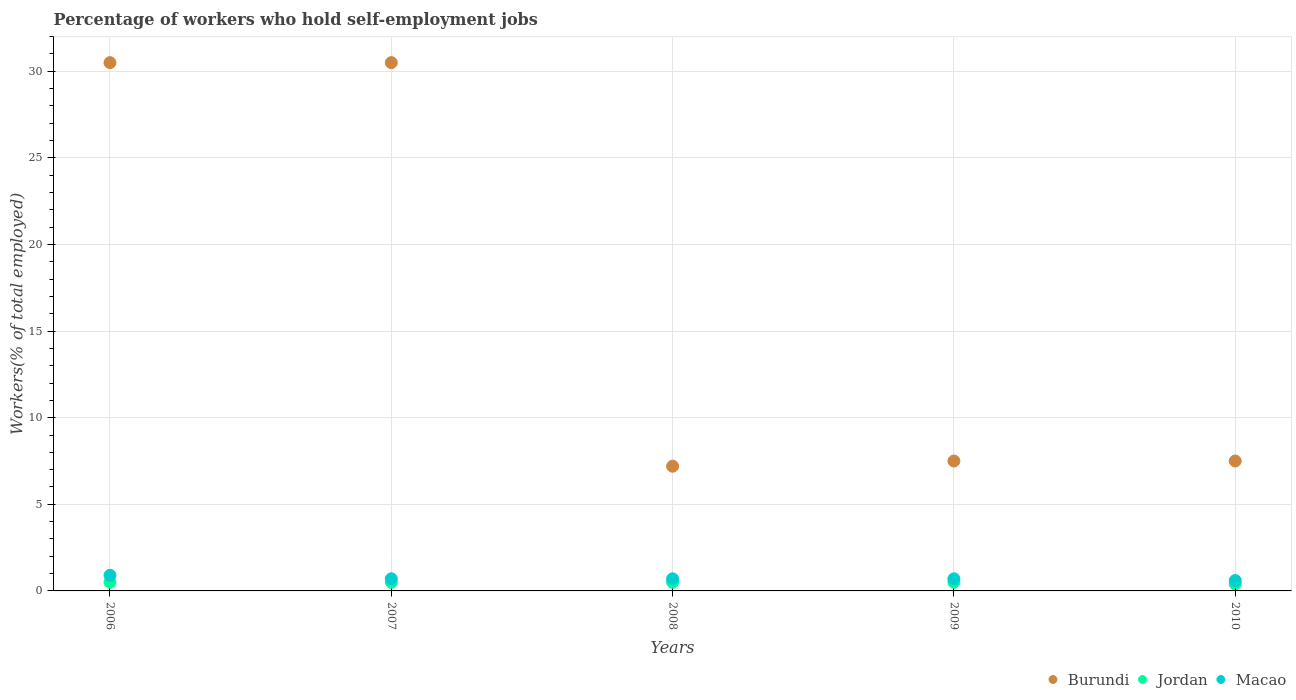Is the number of dotlines equal to the number of legend labels?
Your response must be concise. Yes. What is the percentage of self-employed workers in Macao in 2008?
Give a very brief answer. 0.7. Across all years, what is the maximum percentage of self-employed workers in Burundi?
Your answer should be compact. 30.5. Across all years, what is the minimum percentage of self-employed workers in Jordan?
Provide a succinct answer. 0.4. What is the total percentage of self-employed workers in Jordan in the graph?
Provide a short and direct response. 2.4. What is the average percentage of self-employed workers in Macao per year?
Your answer should be compact. 0.72. In the year 2009, what is the difference between the percentage of self-employed workers in Jordan and percentage of self-employed workers in Macao?
Keep it short and to the point. -0.2. In how many years, is the percentage of self-employed workers in Macao greater than 11 %?
Provide a succinct answer. 0. What is the ratio of the percentage of self-employed workers in Macao in 2007 to that in 2009?
Keep it short and to the point. 1. Is the percentage of self-employed workers in Burundi in 2007 less than that in 2008?
Your answer should be compact. No. Is the difference between the percentage of self-employed workers in Jordan in 2008 and 2010 greater than the difference between the percentage of self-employed workers in Macao in 2008 and 2010?
Provide a short and direct response. Yes. What is the difference between the highest and the lowest percentage of self-employed workers in Macao?
Offer a terse response. 0.3. In how many years, is the percentage of self-employed workers in Jordan greater than the average percentage of self-employed workers in Jordan taken over all years?
Your response must be concise. 4. Is the sum of the percentage of self-employed workers in Macao in 2008 and 2010 greater than the maximum percentage of self-employed workers in Jordan across all years?
Your answer should be compact. Yes. Is the percentage of self-employed workers in Burundi strictly greater than the percentage of self-employed workers in Jordan over the years?
Keep it short and to the point. Yes. Is the percentage of self-employed workers in Jordan strictly less than the percentage of self-employed workers in Macao over the years?
Your answer should be very brief. Yes. How many dotlines are there?
Your answer should be very brief. 3. How many years are there in the graph?
Keep it short and to the point. 5. Does the graph contain any zero values?
Your answer should be compact. No. How many legend labels are there?
Provide a succinct answer. 3. How are the legend labels stacked?
Give a very brief answer. Horizontal. What is the title of the graph?
Provide a succinct answer. Percentage of workers who hold self-employment jobs. What is the label or title of the X-axis?
Provide a succinct answer. Years. What is the label or title of the Y-axis?
Offer a terse response. Workers(% of total employed). What is the Workers(% of total employed) of Burundi in 2006?
Offer a very short reply. 30.5. What is the Workers(% of total employed) in Jordan in 2006?
Keep it short and to the point. 0.5. What is the Workers(% of total employed) in Macao in 2006?
Provide a short and direct response. 0.9. What is the Workers(% of total employed) of Burundi in 2007?
Your answer should be compact. 30.5. What is the Workers(% of total employed) in Macao in 2007?
Provide a short and direct response. 0.7. What is the Workers(% of total employed) of Burundi in 2008?
Make the answer very short. 7.2. What is the Workers(% of total employed) of Macao in 2008?
Give a very brief answer. 0.7. What is the Workers(% of total employed) in Burundi in 2009?
Make the answer very short. 7.5. What is the Workers(% of total employed) of Jordan in 2009?
Ensure brevity in your answer.  0.5. What is the Workers(% of total employed) of Macao in 2009?
Your answer should be very brief. 0.7. What is the Workers(% of total employed) in Burundi in 2010?
Your answer should be very brief. 7.5. What is the Workers(% of total employed) of Jordan in 2010?
Make the answer very short. 0.4. What is the Workers(% of total employed) of Macao in 2010?
Offer a very short reply. 0.6. Across all years, what is the maximum Workers(% of total employed) in Burundi?
Provide a succinct answer. 30.5. Across all years, what is the maximum Workers(% of total employed) in Jordan?
Provide a short and direct response. 0.5. Across all years, what is the maximum Workers(% of total employed) in Macao?
Make the answer very short. 0.9. Across all years, what is the minimum Workers(% of total employed) of Burundi?
Offer a very short reply. 7.2. Across all years, what is the minimum Workers(% of total employed) of Jordan?
Provide a short and direct response. 0.4. Across all years, what is the minimum Workers(% of total employed) in Macao?
Make the answer very short. 0.6. What is the total Workers(% of total employed) in Burundi in the graph?
Give a very brief answer. 83.2. What is the total Workers(% of total employed) of Jordan in the graph?
Provide a succinct answer. 2.4. What is the difference between the Workers(% of total employed) of Macao in 2006 and that in 2007?
Offer a very short reply. 0.2. What is the difference between the Workers(% of total employed) of Burundi in 2006 and that in 2008?
Provide a succinct answer. 23.3. What is the difference between the Workers(% of total employed) of Jordan in 2006 and that in 2010?
Your answer should be compact. 0.1. What is the difference between the Workers(% of total employed) in Macao in 2006 and that in 2010?
Provide a short and direct response. 0.3. What is the difference between the Workers(% of total employed) of Burundi in 2007 and that in 2008?
Provide a short and direct response. 23.3. What is the difference between the Workers(% of total employed) in Jordan in 2007 and that in 2009?
Give a very brief answer. 0. What is the difference between the Workers(% of total employed) in Macao in 2007 and that in 2009?
Ensure brevity in your answer.  0. What is the difference between the Workers(% of total employed) in Burundi in 2007 and that in 2010?
Your response must be concise. 23. What is the difference between the Workers(% of total employed) of Jordan in 2007 and that in 2010?
Offer a very short reply. 0.1. What is the difference between the Workers(% of total employed) of Burundi in 2008 and that in 2009?
Make the answer very short. -0.3. What is the difference between the Workers(% of total employed) of Jordan in 2008 and that in 2009?
Give a very brief answer. 0. What is the difference between the Workers(% of total employed) in Macao in 2008 and that in 2010?
Provide a succinct answer. 0.1. What is the difference between the Workers(% of total employed) of Macao in 2009 and that in 2010?
Your answer should be compact. 0.1. What is the difference between the Workers(% of total employed) in Burundi in 2006 and the Workers(% of total employed) in Macao in 2007?
Provide a succinct answer. 29.8. What is the difference between the Workers(% of total employed) of Jordan in 2006 and the Workers(% of total employed) of Macao in 2007?
Make the answer very short. -0.2. What is the difference between the Workers(% of total employed) of Burundi in 2006 and the Workers(% of total employed) of Macao in 2008?
Keep it short and to the point. 29.8. What is the difference between the Workers(% of total employed) of Jordan in 2006 and the Workers(% of total employed) of Macao in 2008?
Provide a succinct answer. -0.2. What is the difference between the Workers(% of total employed) of Burundi in 2006 and the Workers(% of total employed) of Macao in 2009?
Give a very brief answer. 29.8. What is the difference between the Workers(% of total employed) of Jordan in 2006 and the Workers(% of total employed) of Macao in 2009?
Ensure brevity in your answer.  -0.2. What is the difference between the Workers(% of total employed) of Burundi in 2006 and the Workers(% of total employed) of Jordan in 2010?
Make the answer very short. 30.1. What is the difference between the Workers(% of total employed) in Burundi in 2006 and the Workers(% of total employed) in Macao in 2010?
Provide a succinct answer. 29.9. What is the difference between the Workers(% of total employed) in Burundi in 2007 and the Workers(% of total employed) in Macao in 2008?
Your answer should be compact. 29.8. What is the difference between the Workers(% of total employed) in Jordan in 2007 and the Workers(% of total employed) in Macao in 2008?
Ensure brevity in your answer.  -0.2. What is the difference between the Workers(% of total employed) in Burundi in 2007 and the Workers(% of total employed) in Jordan in 2009?
Make the answer very short. 30. What is the difference between the Workers(% of total employed) in Burundi in 2007 and the Workers(% of total employed) in Macao in 2009?
Provide a succinct answer. 29.8. What is the difference between the Workers(% of total employed) in Burundi in 2007 and the Workers(% of total employed) in Jordan in 2010?
Your answer should be compact. 30.1. What is the difference between the Workers(% of total employed) in Burundi in 2007 and the Workers(% of total employed) in Macao in 2010?
Your response must be concise. 29.9. What is the difference between the Workers(% of total employed) of Burundi in 2008 and the Workers(% of total employed) of Jordan in 2009?
Provide a short and direct response. 6.7. What is the difference between the Workers(% of total employed) of Burundi in 2008 and the Workers(% of total employed) of Macao in 2009?
Provide a short and direct response. 6.5. What is the difference between the Workers(% of total employed) of Burundi in 2009 and the Workers(% of total employed) of Jordan in 2010?
Provide a succinct answer. 7.1. What is the difference between the Workers(% of total employed) in Burundi in 2009 and the Workers(% of total employed) in Macao in 2010?
Your response must be concise. 6.9. What is the average Workers(% of total employed) in Burundi per year?
Give a very brief answer. 16.64. What is the average Workers(% of total employed) in Jordan per year?
Your answer should be very brief. 0.48. What is the average Workers(% of total employed) of Macao per year?
Provide a succinct answer. 0.72. In the year 2006, what is the difference between the Workers(% of total employed) of Burundi and Workers(% of total employed) of Jordan?
Keep it short and to the point. 30. In the year 2006, what is the difference between the Workers(% of total employed) of Burundi and Workers(% of total employed) of Macao?
Ensure brevity in your answer.  29.6. In the year 2007, what is the difference between the Workers(% of total employed) in Burundi and Workers(% of total employed) in Jordan?
Give a very brief answer. 30. In the year 2007, what is the difference between the Workers(% of total employed) of Burundi and Workers(% of total employed) of Macao?
Provide a succinct answer. 29.8. In the year 2007, what is the difference between the Workers(% of total employed) in Jordan and Workers(% of total employed) in Macao?
Provide a short and direct response. -0.2. In the year 2008, what is the difference between the Workers(% of total employed) of Burundi and Workers(% of total employed) of Jordan?
Provide a succinct answer. 6.7. In the year 2009, what is the difference between the Workers(% of total employed) of Burundi and Workers(% of total employed) of Jordan?
Provide a short and direct response. 7. In the year 2010, what is the difference between the Workers(% of total employed) in Burundi and Workers(% of total employed) in Jordan?
Provide a short and direct response. 7.1. In the year 2010, what is the difference between the Workers(% of total employed) of Jordan and Workers(% of total employed) of Macao?
Provide a succinct answer. -0.2. What is the ratio of the Workers(% of total employed) of Burundi in 2006 to that in 2007?
Give a very brief answer. 1. What is the ratio of the Workers(% of total employed) of Burundi in 2006 to that in 2008?
Offer a terse response. 4.24. What is the ratio of the Workers(% of total employed) in Burundi in 2006 to that in 2009?
Offer a terse response. 4.07. What is the ratio of the Workers(% of total employed) in Jordan in 2006 to that in 2009?
Offer a terse response. 1. What is the ratio of the Workers(% of total employed) in Burundi in 2006 to that in 2010?
Your answer should be compact. 4.07. What is the ratio of the Workers(% of total employed) of Burundi in 2007 to that in 2008?
Your answer should be very brief. 4.24. What is the ratio of the Workers(% of total employed) of Jordan in 2007 to that in 2008?
Your answer should be very brief. 1. What is the ratio of the Workers(% of total employed) of Macao in 2007 to that in 2008?
Your answer should be very brief. 1. What is the ratio of the Workers(% of total employed) in Burundi in 2007 to that in 2009?
Offer a very short reply. 4.07. What is the ratio of the Workers(% of total employed) of Jordan in 2007 to that in 2009?
Provide a succinct answer. 1. What is the ratio of the Workers(% of total employed) in Burundi in 2007 to that in 2010?
Provide a short and direct response. 4.07. What is the ratio of the Workers(% of total employed) in Burundi in 2008 to that in 2010?
Your answer should be very brief. 0.96. What is the ratio of the Workers(% of total employed) of Jordan in 2008 to that in 2010?
Your response must be concise. 1.25. What is the ratio of the Workers(% of total employed) of Macao in 2008 to that in 2010?
Offer a terse response. 1.17. What is the ratio of the Workers(% of total employed) in Burundi in 2009 to that in 2010?
Make the answer very short. 1. What is the difference between the highest and the second highest Workers(% of total employed) of Jordan?
Give a very brief answer. 0. What is the difference between the highest and the second highest Workers(% of total employed) of Macao?
Provide a short and direct response. 0.2. What is the difference between the highest and the lowest Workers(% of total employed) of Burundi?
Give a very brief answer. 23.3. What is the difference between the highest and the lowest Workers(% of total employed) of Jordan?
Ensure brevity in your answer.  0.1. 